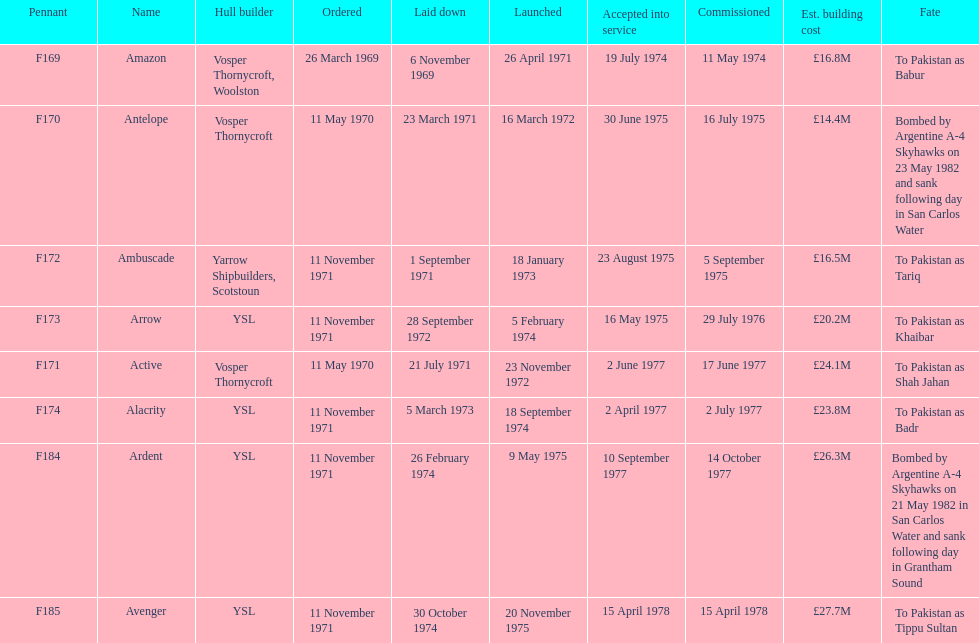Indicate the total of ships that voyaged to pakistan. 6. Would you be able to parse every entry in this table? {'header': ['Pennant', 'Name', 'Hull builder', 'Ordered', 'Laid down', 'Launched', 'Accepted into service', 'Commissioned', 'Est. building cost', 'Fate'], 'rows': [['F169', 'Amazon', 'Vosper Thornycroft, Woolston', '26 March 1969', '6 November 1969', '26 April 1971', '19 July 1974', '11 May 1974', '£16.8M', 'To Pakistan as Babur'], ['F170', 'Antelope', 'Vosper Thornycroft', '11 May 1970', '23 March 1971', '16 March 1972', '30 June 1975', '16 July 1975', '£14.4M', 'Bombed by Argentine A-4 Skyhawks on 23 May 1982 and sank following day in San Carlos Water'], ['F172', 'Ambuscade', 'Yarrow Shipbuilders, Scotstoun', '11 November 1971', '1 September 1971', '18 January 1973', '23 August 1975', '5 September 1975', '£16.5M', 'To Pakistan as Tariq'], ['F173', 'Arrow', 'YSL', '11 November 1971', '28 September 1972', '5 February 1974', '16 May 1975', '29 July 1976', '£20.2M', 'To Pakistan as Khaibar'], ['F171', 'Active', 'Vosper Thornycroft', '11 May 1970', '21 July 1971', '23 November 1972', '2 June 1977', '17 June 1977', '£24.1M', 'To Pakistan as Shah Jahan'], ['F174', 'Alacrity', 'YSL', '11 November 1971', '5 March 1973', '18 September 1974', '2 April 1977', '2 July 1977', '£23.8M', 'To Pakistan as Badr'], ['F184', 'Ardent', 'YSL', '11 November 1971', '26 February 1974', '9 May 1975', '10 September 1977', '14 October 1977', '£26.3M', 'Bombed by Argentine A-4 Skyhawks on 21 May 1982 in San Carlos Water and sank following day in Grantham Sound'], ['F185', 'Avenger', 'YSL', '11 November 1971', '30 October 1974', '20 November 1975', '15 April 1978', '15 April 1978', '£27.7M', 'To Pakistan as Tippu Sultan']]} 